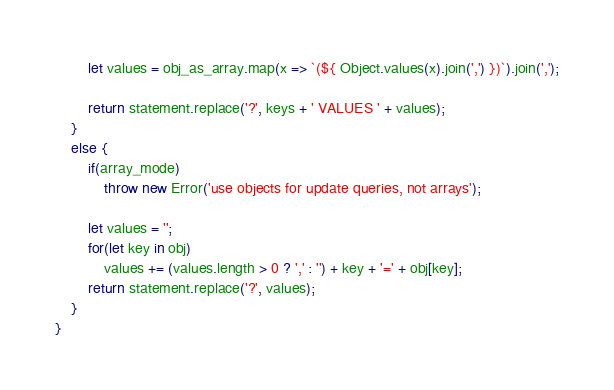Convert code to text. <code><loc_0><loc_0><loc_500><loc_500><_JavaScript_>        let values = obj_as_array.map(x => `(${ Object.values(x).join(',') })`).join(',');
        
        return statement.replace('?', keys + ' VALUES ' + values);
    }
    else {
        if(array_mode)
            throw new Error('use objects for update queries, not arrays');

        let values = '';
        for(let key in obj)
            values += (values.length > 0 ? ',' : '') + key + '=' + obj[key];
        return statement.replace('?', values);
    }
}</code> 